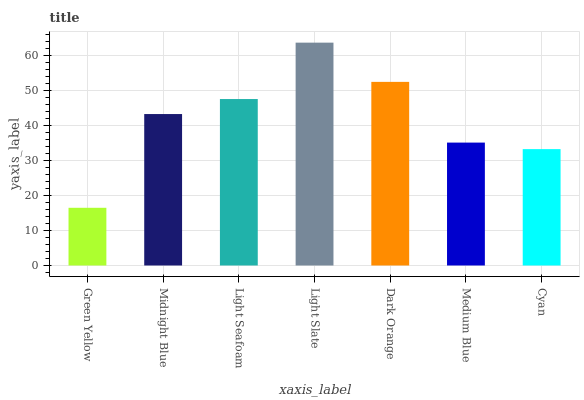Is Midnight Blue the minimum?
Answer yes or no. No. Is Midnight Blue the maximum?
Answer yes or no. No. Is Midnight Blue greater than Green Yellow?
Answer yes or no. Yes. Is Green Yellow less than Midnight Blue?
Answer yes or no. Yes. Is Green Yellow greater than Midnight Blue?
Answer yes or no. No. Is Midnight Blue less than Green Yellow?
Answer yes or no. No. Is Midnight Blue the high median?
Answer yes or no. Yes. Is Midnight Blue the low median?
Answer yes or no. Yes. Is Green Yellow the high median?
Answer yes or no. No. Is Cyan the low median?
Answer yes or no. No. 